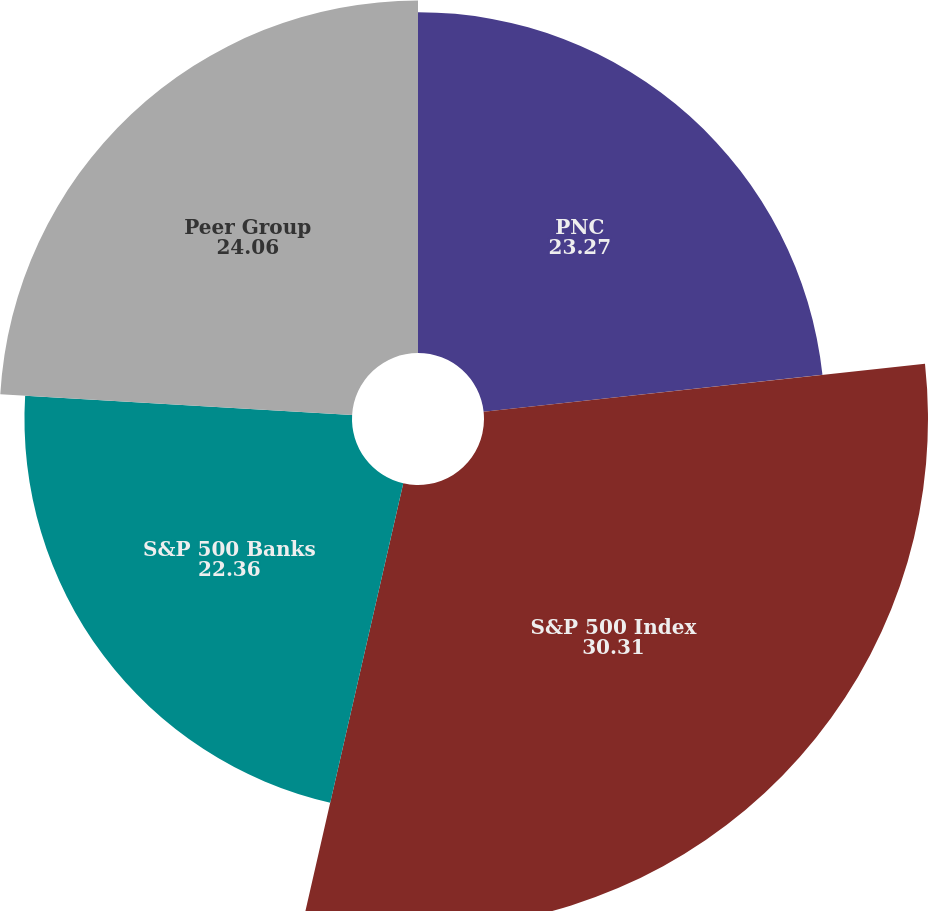<chart> <loc_0><loc_0><loc_500><loc_500><pie_chart><fcel>PNC<fcel>S&P 500 Index<fcel>S&P 500 Banks<fcel>Peer Group<nl><fcel>23.27%<fcel>30.31%<fcel>22.36%<fcel>24.06%<nl></chart> 